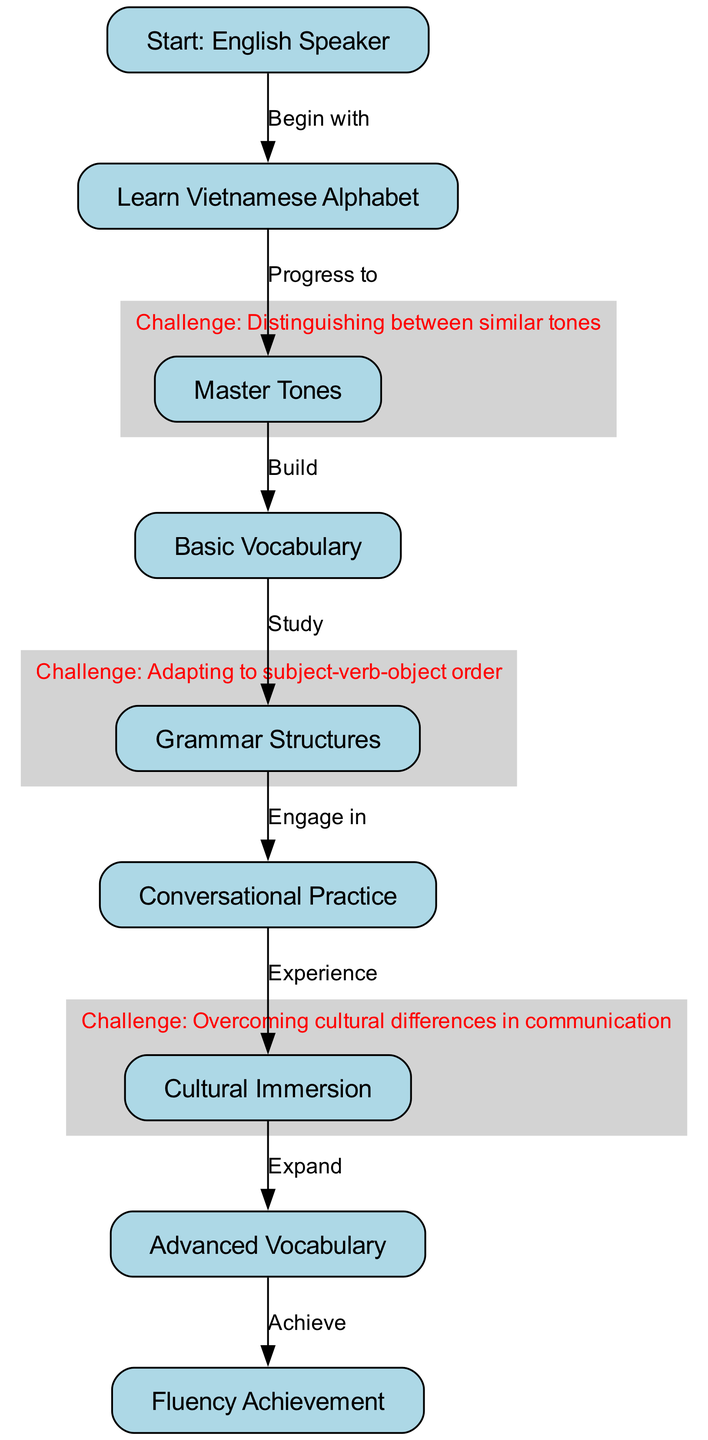What is the first step for an English speaker learning Vietnamese? The diagram indicates that the starting point for an English speaker is "Start: English Speaker." This is represented as the first node in the flowchart.
Answer: Start: English Speaker How many nodes are present in the flowchart? By counting the provided nodes in the diagram, we can see there are a total of 9 distinct nodes.
Answer: 9 What challenge is associated with mastering tones? The flowchart specifies a challenge for mastering tones as "Distinguishing between similar tones." This is directly linked to the node for mastering tones.
Answer: Distinguishing between similar tones What follows after learning basic vocabulary? The diagram shows that after "Basic Vocabulary," the next stage is "Grammar Structures." This indicates a progression in the language learning process.
Answer: Grammar Structures Which stage includes cultural immersion? According to the diagram, "Cultural Immersion" is a node that comes after "Conversational Practice." This implies that both practice and immersion are necessary for deeper understanding.
Answer: Cultural Immersion What is required before achieving fluency? The flowchart indicates that before "Fluency Achievement," learners must expand their knowledge to "Advanced Vocabulary." This suggests that advanced vocabulary is essential for fluency.
Answer: Advanced Vocabulary How does one transition from conversational practice to cultural immersion? The diagram shows an edge from the node "Conversational Practice" to the node "Cultural Immersion," labeled "Experience." This indicates a direct relationship between the two stages.
Answer: Experience What does the relationship between mastering tones and basic vocabulary convey? The flowchart states that mastering tones is a prerequisite for building basic vocabulary, as "Build" connects the two. This means that understanding tones is foundational for vocabulary learning.
Answer: Build At which stage do learners begin to engage in conversational practice? The diagram shows the transition from "Grammar Structures" to "Conversational Practice," indicating that conversational practice comes directly after mastering grammar.
Answer: Conversational Practice 